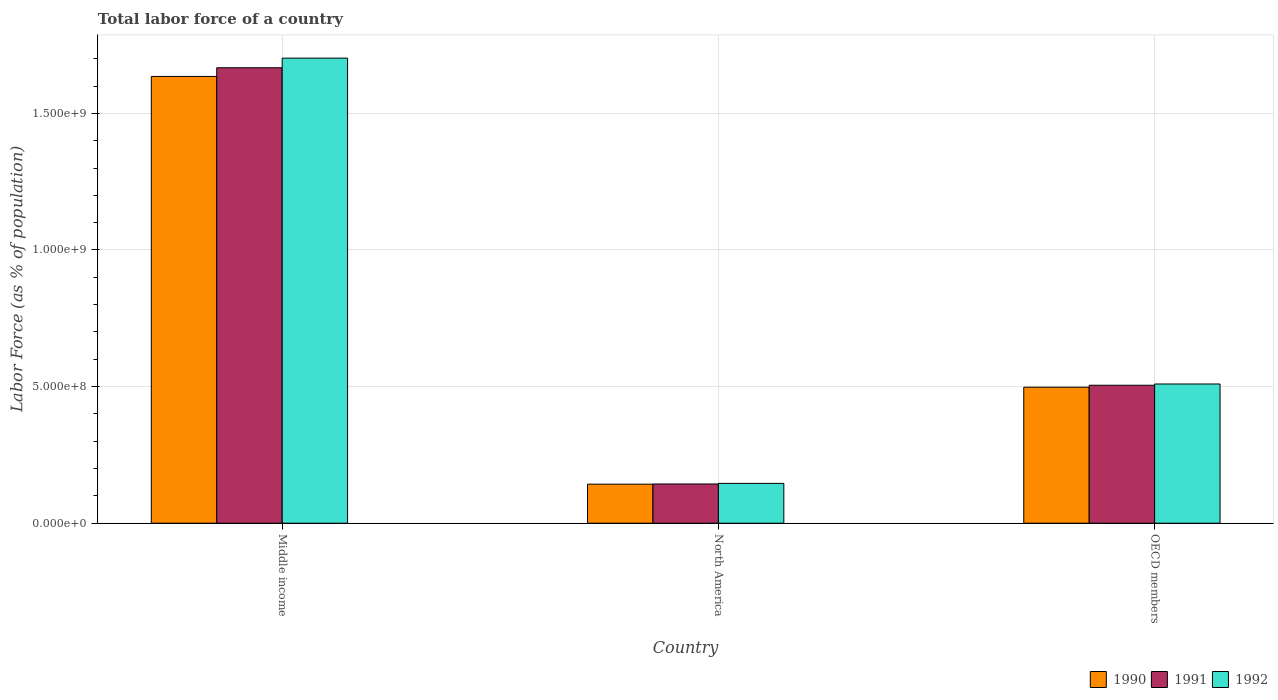How many different coloured bars are there?
Your answer should be very brief. 3. How many groups of bars are there?
Offer a very short reply. 3. Are the number of bars per tick equal to the number of legend labels?
Give a very brief answer. Yes. Are the number of bars on each tick of the X-axis equal?
Your response must be concise. Yes. How many bars are there on the 2nd tick from the right?
Offer a very short reply. 3. In how many cases, is the number of bars for a given country not equal to the number of legend labels?
Your answer should be compact. 0. What is the percentage of labor force in 1991 in OECD members?
Offer a very short reply. 5.05e+08. Across all countries, what is the maximum percentage of labor force in 1991?
Provide a succinct answer. 1.67e+09. Across all countries, what is the minimum percentage of labor force in 1992?
Provide a succinct answer. 1.46e+08. In which country was the percentage of labor force in 1992 maximum?
Make the answer very short. Middle income. In which country was the percentage of labor force in 1991 minimum?
Offer a very short reply. North America. What is the total percentage of labor force in 1991 in the graph?
Offer a terse response. 2.32e+09. What is the difference between the percentage of labor force in 1990 in North America and that in OECD members?
Provide a succinct answer. -3.55e+08. What is the difference between the percentage of labor force in 1992 in North America and the percentage of labor force in 1990 in Middle income?
Offer a very short reply. -1.49e+09. What is the average percentage of labor force in 1992 per country?
Offer a terse response. 7.86e+08. What is the difference between the percentage of labor force of/in 1990 and percentage of labor force of/in 1991 in Middle income?
Give a very brief answer. -3.18e+07. What is the ratio of the percentage of labor force in 1992 in Middle income to that in North America?
Offer a very short reply. 11.67. Is the percentage of labor force in 1992 in Middle income less than that in OECD members?
Ensure brevity in your answer.  No. Is the difference between the percentage of labor force in 1990 in Middle income and OECD members greater than the difference between the percentage of labor force in 1991 in Middle income and OECD members?
Provide a short and direct response. No. What is the difference between the highest and the second highest percentage of labor force in 1990?
Provide a succinct answer. -1.14e+09. What is the difference between the highest and the lowest percentage of labor force in 1992?
Your answer should be compact. 1.56e+09. Is the sum of the percentage of labor force in 1990 in Middle income and North America greater than the maximum percentage of labor force in 1992 across all countries?
Offer a very short reply. Yes. What does the 3rd bar from the left in North America represents?
Offer a very short reply. 1992. Is it the case that in every country, the sum of the percentage of labor force in 1991 and percentage of labor force in 1992 is greater than the percentage of labor force in 1990?
Provide a succinct answer. Yes. How many countries are there in the graph?
Your response must be concise. 3. What is the difference between two consecutive major ticks on the Y-axis?
Your response must be concise. 5.00e+08. Are the values on the major ticks of Y-axis written in scientific E-notation?
Provide a succinct answer. Yes. Does the graph contain any zero values?
Keep it short and to the point. No. Does the graph contain grids?
Keep it short and to the point. Yes. What is the title of the graph?
Offer a terse response. Total labor force of a country. Does "1976" appear as one of the legend labels in the graph?
Your answer should be compact. No. What is the label or title of the X-axis?
Make the answer very short. Country. What is the label or title of the Y-axis?
Offer a terse response. Labor Force (as % of population). What is the Labor Force (as % of population) in 1990 in Middle income?
Make the answer very short. 1.64e+09. What is the Labor Force (as % of population) of 1991 in Middle income?
Provide a succinct answer. 1.67e+09. What is the Labor Force (as % of population) of 1992 in Middle income?
Provide a short and direct response. 1.70e+09. What is the Labor Force (as % of population) of 1990 in North America?
Offer a very short reply. 1.43e+08. What is the Labor Force (as % of population) in 1991 in North America?
Your response must be concise. 1.44e+08. What is the Labor Force (as % of population) in 1992 in North America?
Your answer should be compact. 1.46e+08. What is the Labor Force (as % of population) of 1990 in OECD members?
Offer a very short reply. 4.98e+08. What is the Labor Force (as % of population) in 1991 in OECD members?
Make the answer very short. 5.05e+08. What is the Labor Force (as % of population) in 1992 in OECD members?
Offer a terse response. 5.10e+08. Across all countries, what is the maximum Labor Force (as % of population) in 1990?
Ensure brevity in your answer.  1.64e+09. Across all countries, what is the maximum Labor Force (as % of population) in 1991?
Provide a succinct answer. 1.67e+09. Across all countries, what is the maximum Labor Force (as % of population) in 1992?
Give a very brief answer. 1.70e+09. Across all countries, what is the minimum Labor Force (as % of population) in 1990?
Make the answer very short. 1.43e+08. Across all countries, what is the minimum Labor Force (as % of population) in 1991?
Give a very brief answer. 1.44e+08. Across all countries, what is the minimum Labor Force (as % of population) of 1992?
Your answer should be very brief. 1.46e+08. What is the total Labor Force (as % of population) of 1990 in the graph?
Make the answer very short. 2.28e+09. What is the total Labor Force (as % of population) in 1991 in the graph?
Offer a very short reply. 2.32e+09. What is the total Labor Force (as % of population) in 1992 in the graph?
Give a very brief answer. 2.36e+09. What is the difference between the Labor Force (as % of population) in 1990 in Middle income and that in North America?
Offer a very short reply. 1.49e+09. What is the difference between the Labor Force (as % of population) of 1991 in Middle income and that in North America?
Offer a terse response. 1.52e+09. What is the difference between the Labor Force (as % of population) in 1992 in Middle income and that in North America?
Provide a short and direct response. 1.56e+09. What is the difference between the Labor Force (as % of population) in 1990 in Middle income and that in OECD members?
Provide a short and direct response. 1.14e+09. What is the difference between the Labor Force (as % of population) in 1991 in Middle income and that in OECD members?
Your answer should be very brief. 1.16e+09. What is the difference between the Labor Force (as % of population) of 1992 in Middle income and that in OECD members?
Your answer should be very brief. 1.19e+09. What is the difference between the Labor Force (as % of population) in 1990 in North America and that in OECD members?
Your response must be concise. -3.55e+08. What is the difference between the Labor Force (as % of population) of 1991 in North America and that in OECD members?
Provide a short and direct response. -3.61e+08. What is the difference between the Labor Force (as % of population) of 1992 in North America and that in OECD members?
Ensure brevity in your answer.  -3.64e+08. What is the difference between the Labor Force (as % of population) of 1990 in Middle income and the Labor Force (as % of population) of 1991 in North America?
Keep it short and to the point. 1.49e+09. What is the difference between the Labor Force (as % of population) in 1990 in Middle income and the Labor Force (as % of population) in 1992 in North America?
Your response must be concise. 1.49e+09. What is the difference between the Labor Force (as % of population) in 1991 in Middle income and the Labor Force (as % of population) in 1992 in North America?
Your response must be concise. 1.52e+09. What is the difference between the Labor Force (as % of population) of 1990 in Middle income and the Labor Force (as % of population) of 1991 in OECD members?
Offer a very short reply. 1.13e+09. What is the difference between the Labor Force (as % of population) of 1990 in Middle income and the Labor Force (as % of population) of 1992 in OECD members?
Provide a succinct answer. 1.13e+09. What is the difference between the Labor Force (as % of population) in 1991 in Middle income and the Labor Force (as % of population) in 1992 in OECD members?
Ensure brevity in your answer.  1.16e+09. What is the difference between the Labor Force (as % of population) in 1990 in North America and the Labor Force (as % of population) in 1991 in OECD members?
Provide a short and direct response. -3.62e+08. What is the difference between the Labor Force (as % of population) in 1990 in North America and the Labor Force (as % of population) in 1992 in OECD members?
Your answer should be very brief. -3.67e+08. What is the difference between the Labor Force (as % of population) of 1991 in North America and the Labor Force (as % of population) of 1992 in OECD members?
Ensure brevity in your answer.  -3.66e+08. What is the average Labor Force (as % of population) of 1990 per country?
Provide a short and direct response. 7.59e+08. What is the average Labor Force (as % of population) of 1991 per country?
Your answer should be very brief. 7.72e+08. What is the average Labor Force (as % of population) in 1992 per country?
Your answer should be compact. 7.86e+08. What is the difference between the Labor Force (as % of population) of 1990 and Labor Force (as % of population) of 1991 in Middle income?
Your answer should be very brief. -3.18e+07. What is the difference between the Labor Force (as % of population) of 1990 and Labor Force (as % of population) of 1992 in Middle income?
Keep it short and to the point. -6.70e+07. What is the difference between the Labor Force (as % of population) in 1991 and Labor Force (as % of population) in 1992 in Middle income?
Provide a succinct answer. -3.52e+07. What is the difference between the Labor Force (as % of population) in 1990 and Labor Force (as % of population) in 1991 in North America?
Give a very brief answer. -6.85e+05. What is the difference between the Labor Force (as % of population) in 1990 and Labor Force (as % of population) in 1992 in North America?
Keep it short and to the point. -2.92e+06. What is the difference between the Labor Force (as % of population) of 1991 and Labor Force (as % of population) of 1992 in North America?
Your answer should be very brief. -2.23e+06. What is the difference between the Labor Force (as % of population) in 1990 and Labor Force (as % of population) in 1991 in OECD members?
Give a very brief answer. -7.11e+06. What is the difference between the Labor Force (as % of population) in 1990 and Labor Force (as % of population) in 1992 in OECD members?
Your answer should be very brief. -1.17e+07. What is the difference between the Labor Force (as % of population) of 1991 and Labor Force (as % of population) of 1992 in OECD members?
Provide a succinct answer. -4.58e+06. What is the ratio of the Labor Force (as % of population) in 1990 in Middle income to that in North America?
Keep it short and to the point. 11.44. What is the ratio of the Labor Force (as % of population) in 1991 in Middle income to that in North America?
Your answer should be compact. 11.61. What is the ratio of the Labor Force (as % of population) of 1992 in Middle income to that in North America?
Your answer should be compact. 11.67. What is the ratio of the Labor Force (as % of population) of 1990 in Middle income to that in OECD members?
Provide a short and direct response. 3.28. What is the ratio of the Labor Force (as % of population) in 1991 in Middle income to that in OECD members?
Offer a terse response. 3.3. What is the ratio of the Labor Force (as % of population) of 1992 in Middle income to that in OECD members?
Offer a very short reply. 3.34. What is the ratio of the Labor Force (as % of population) in 1990 in North America to that in OECD members?
Keep it short and to the point. 0.29. What is the ratio of the Labor Force (as % of population) of 1991 in North America to that in OECD members?
Make the answer very short. 0.28. What is the ratio of the Labor Force (as % of population) in 1992 in North America to that in OECD members?
Ensure brevity in your answer.  0.29. What is the difference between the highest and the second highest Labor Force (as % of population) in 1990?
Make the answer very short. 1.14e+09. What is the difference between the highest and the second highest Labor Force (as % of population) of 1991?
Your answer should be compact. 1.16e+09. What is the difference between the highest and the second highest Labor Force (as % of population) in 1992?
Your response must be concise. 1.19e+09. What is the difference between the highest and the lowest Labor Force (as % of population) in 1990?
Provide a succinct answer. 1.49e+09. What is the difference between the highest and the lowest Labor Force (as % of population) of 1991?
Offer a terse response. 1.52e+09. What is the difference between the highest and the lowest Labor Force (as % of population) in 1992?
Your answer should be compact. 1.56e+09. 